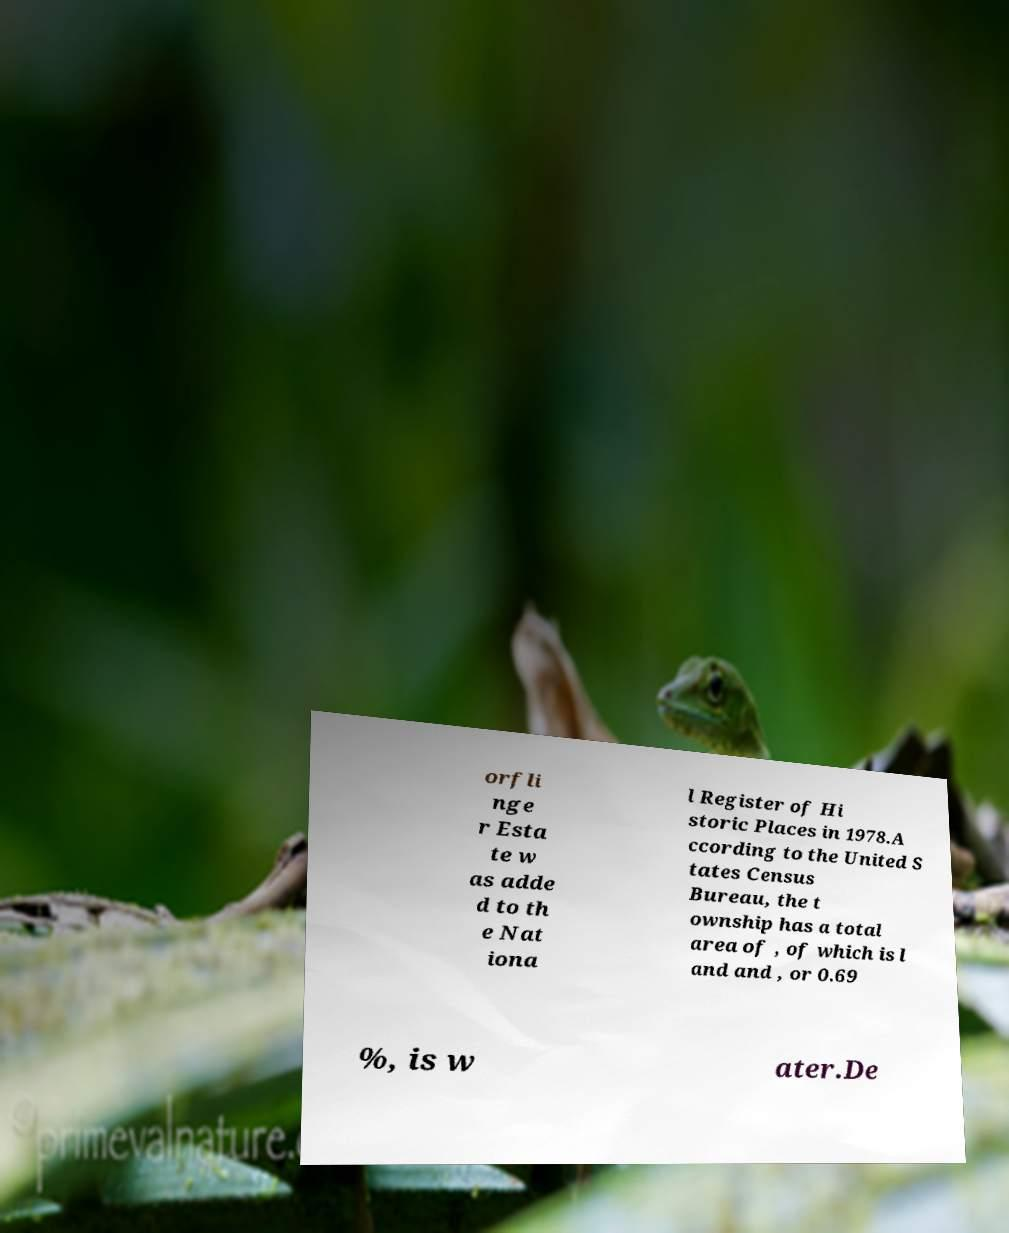There's text embedded in this image that I need extracted. Can you transcribe it verbatim? orfli nge r Esta te w as adde d to th e Nat iona l Register of Hi storic Places in 1978.A ccording to the United S tates Census Bureau, the t ownship has a total area of , of which is l and and , or 0.69 %, is w ater.De 